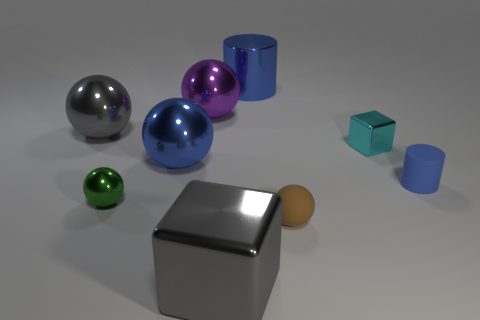How would you describe the arrangement of objects in this scene? The objects are arranged sporadically on a flat surface with varying distances between them. They don't seem to follow a specific pattern, each item positioned as if placed randomly across the space. 